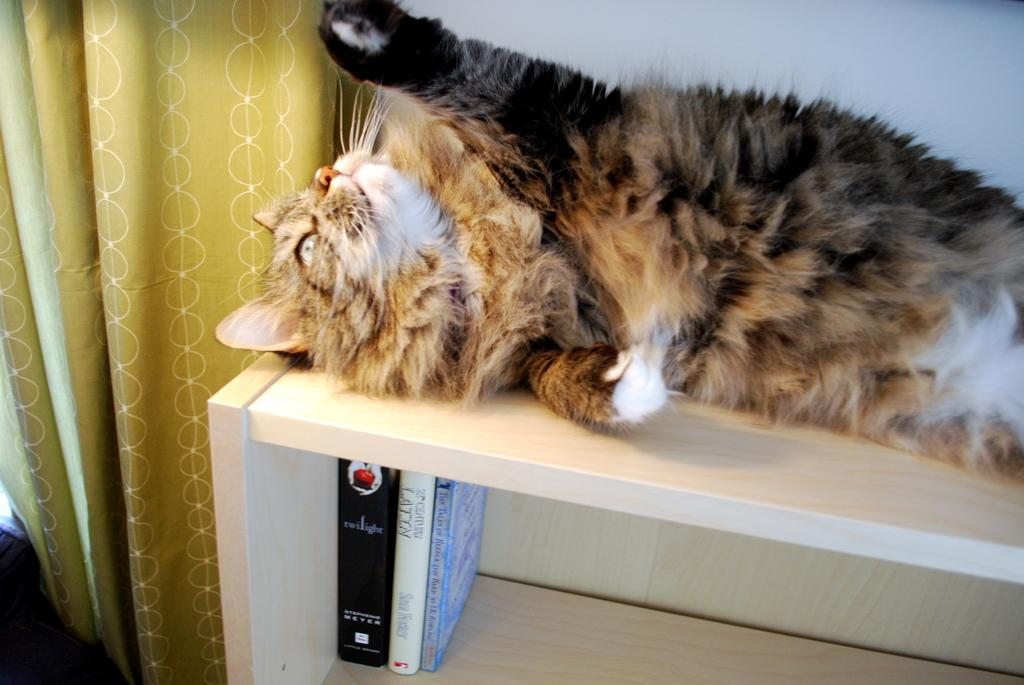What animal can be seen in the image? There is a cat laying on a table in the image. What items are stored in the table cabinet? There are books in the table cabinet. What type of window treatment is present in the image? There is a curtain on the left side of the image. Where is the curtain attached? The curtain is attached to a wall. What type of wound can be seen on the cat in the image? There is no wound visible on the cat in the image. How many ants are crawling on the table in the image? There are no ants present in the image. 